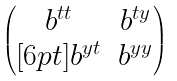Convert formula to latex. <formula><loc_0><loc_0><loc_500><loc_500>\begin{pmatrix} b ^ { t t } & b ^ { t y } \\ [ 6 p t ] b ^ { y t } & b ^ { y y } \end{pmatrix}</formula> 